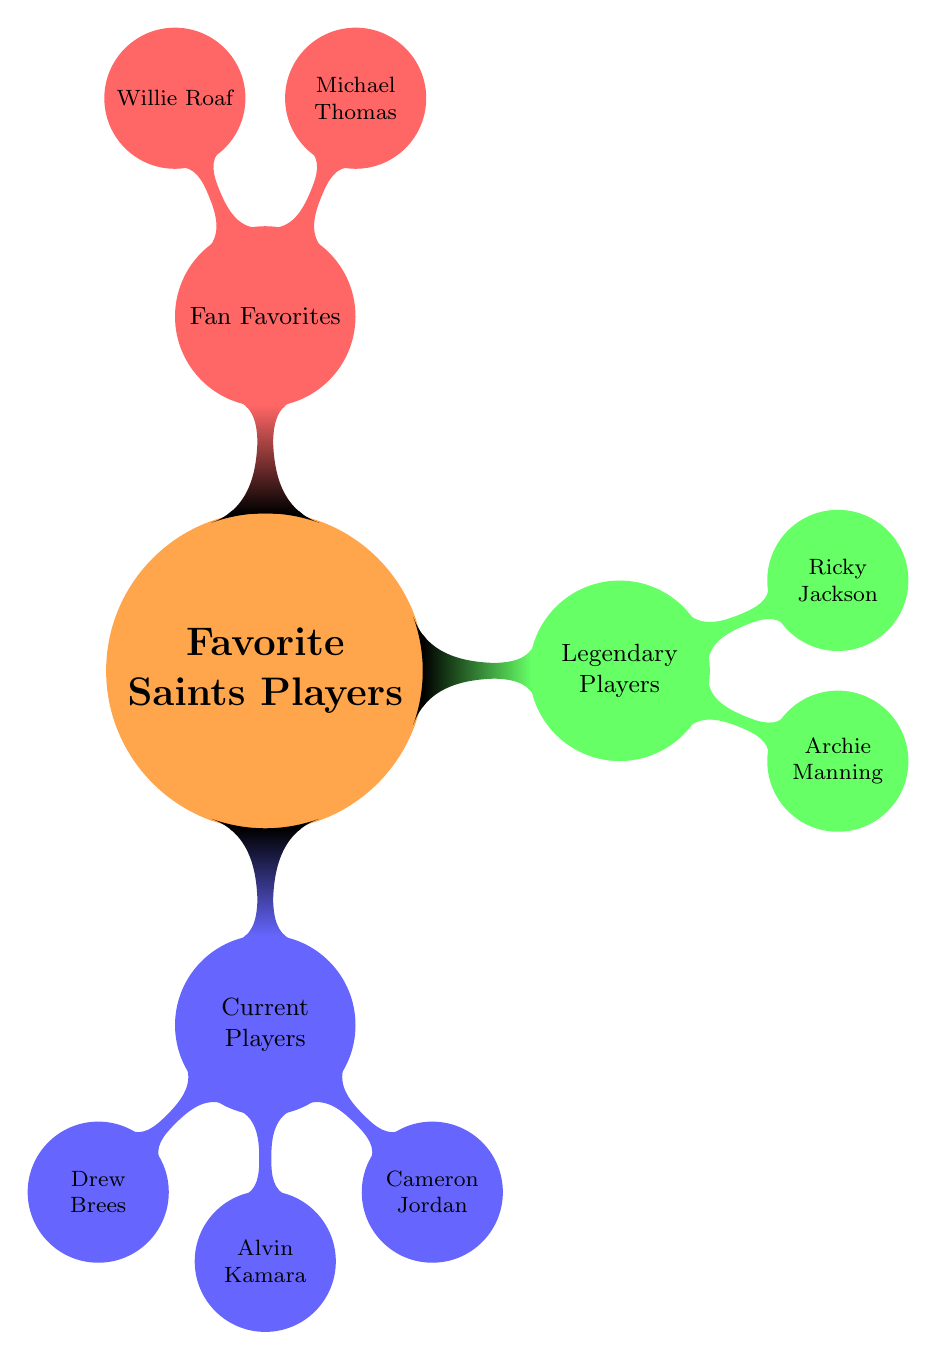What are the types of players listed in the diagram? The diagram categorizes the players into three types: Current Players, Legendary Players, and Fan Favorites.
Answer: Current Players, Legendary Players, Fan Favorites How many Current Players are listed? There are three current players mentioned in the diagram: Drew Brees, Alvin Kamara, and Cameron Jordan.
Answer: 3 Who is the Defensive End among the Current Players? The diagram indicates that Cameron Jordan is categorized as a Defensive End under Current Players.
Answer: Cameron Jordan How many Legendary Players are included? The diagram shows that there are two legendary players: Archie Manning and Ricky Jackson, which means there are two nodes under this category.
Answer: 2 Which Current Player has the most Pro Bowl selections? By examining the achievements, Drew Brees has 13 Pro Bowl selections, which is the highest among the current players listed.
Answer: Drew Brees What position does Michael Thomas play? The diagram indicates that Michael Thomas is categorized as a Wide Receiver under the Fan Favorites section.
Answer: Wide Receiver Who among the Legendary Players is a Hall of Fame Inductee? The diagram specifies that Ricky Jackson is a Pro Football Hall of Fame Inductee.
Answer: Ricky Jackson What is the position of Alvin Kamara? The diagram clearly specifies that Alvin Kamara plays the Running Back position under Current Players.
Answer: Running Back What achievements does Willie Roaf have? Looking at the diagram, Willie Roaf is recognized as a Pro Football Hall of Fame Inductee and an 11-time Pro Bowl Selection, which are his major achievements.
Answer: Pro Football Hall of Fame Inductee, 11-time Pro Bowl Selection 